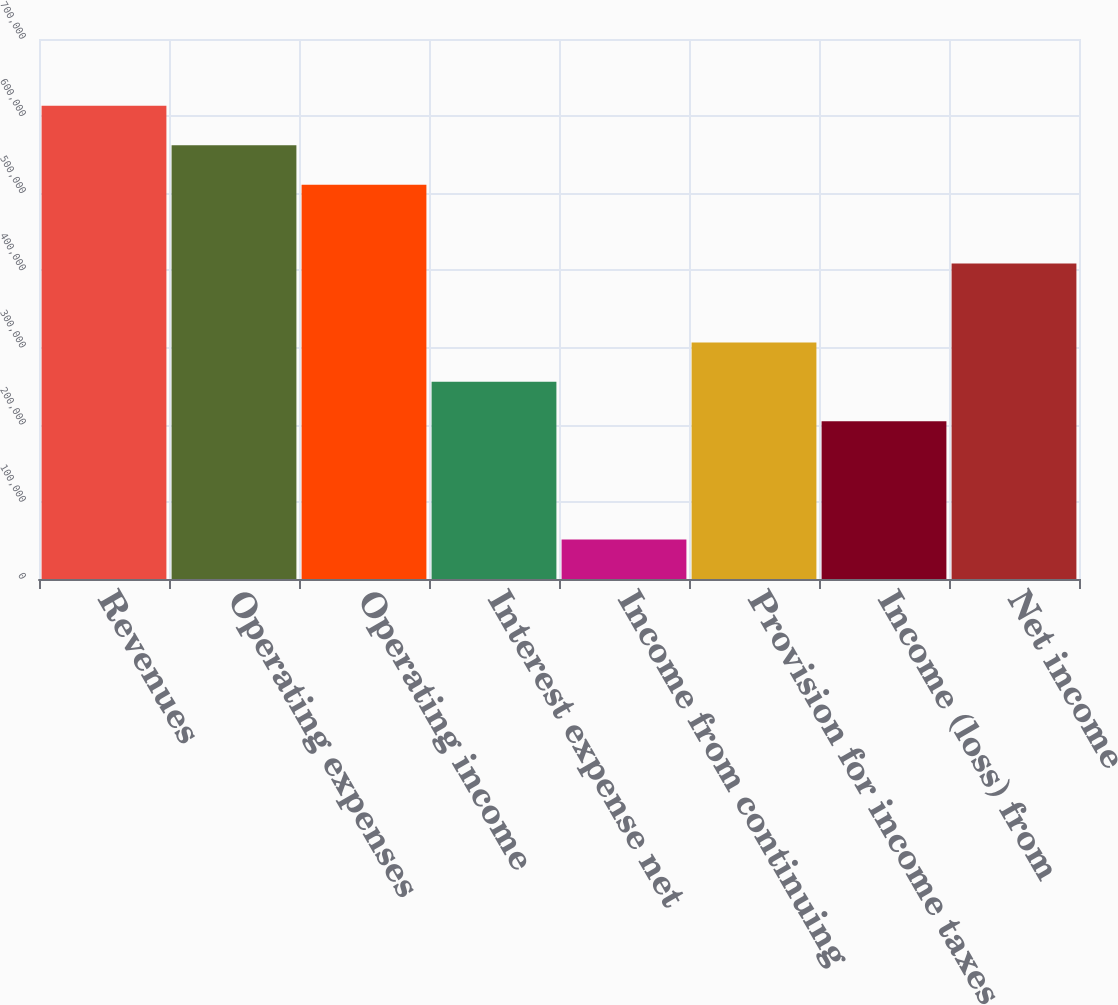Convert chart to OTSL. <chart><loc_0><loc_0><loc_500><loc_500><bar_chart><fcel>Revenues<fcel>Operating expenses<fcel>Operating income<fcel>Interest expense net<fcel>Income from continuing<fcel>Provision for income taxes<fcel>Income (loss) from<fcel>Net income<nl><fcel>613470<fcel>562347<fcel>511225<fcel>255613<fcel>51123.3<fcel>306735<fcel>204491<fcel>408980<nl></chart> 